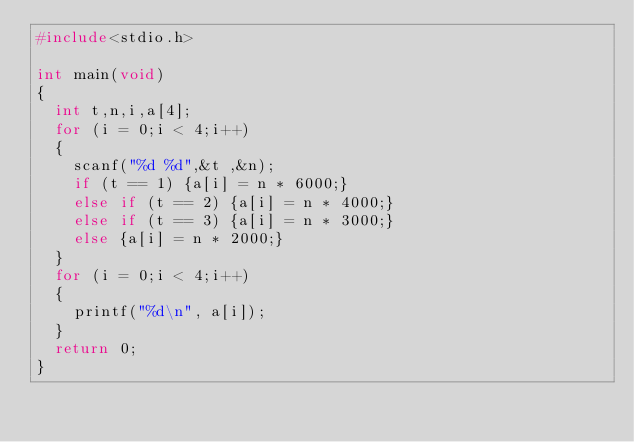Convert code to text. <code><loc_0><loc_0><loc_500><loc_500><_C_>#include<stdio.h>

int main(void)
{
	int t,n,i,a[4];
	for (i = 0;i < 4;i++)
	{
		scanf("%d %d",&t ,&n);
		if (t == 1) {a[i] = n * 6000;}
		else if (t == 2) {a[i] = n * 4000;}
		else if (t == 3) {a[i] = n * 3000;}
		else {a[i] = n * 2000;}
	}
	for (i = 0;i < 4;i++)
	{
		printf("%d\n", a[i]);
	}
	return 0;
}</code> 